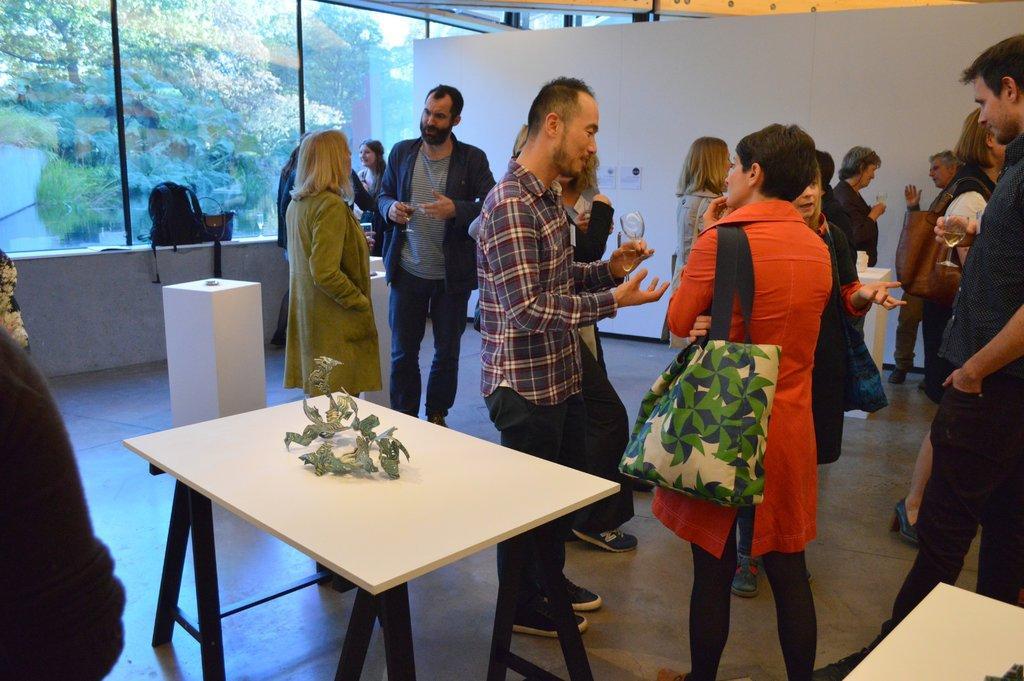In one or two sentences, can you explain what this image depicts? In this picture all persons are standing. On a table there is a bag. This is a white table. This woman wore orange jacket and bag. This man holds glass. Outside of the window there are trees. 